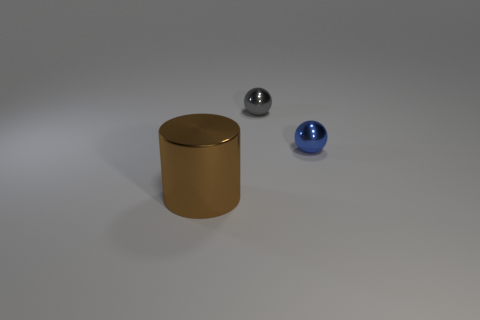Add 2 metallic things. How many objects exist? 5 Subtract all balls. How many objects are left? 1 Add 3 gray things. How many gray things are left? 4 Add 1 metal cylinders. How many metal cylinders exist? 2 Subtract 0 purple blocks. How many objects are left? 3 Subtract all green shiny balls. Subtract all big cylinders. How many objects are left? 2 